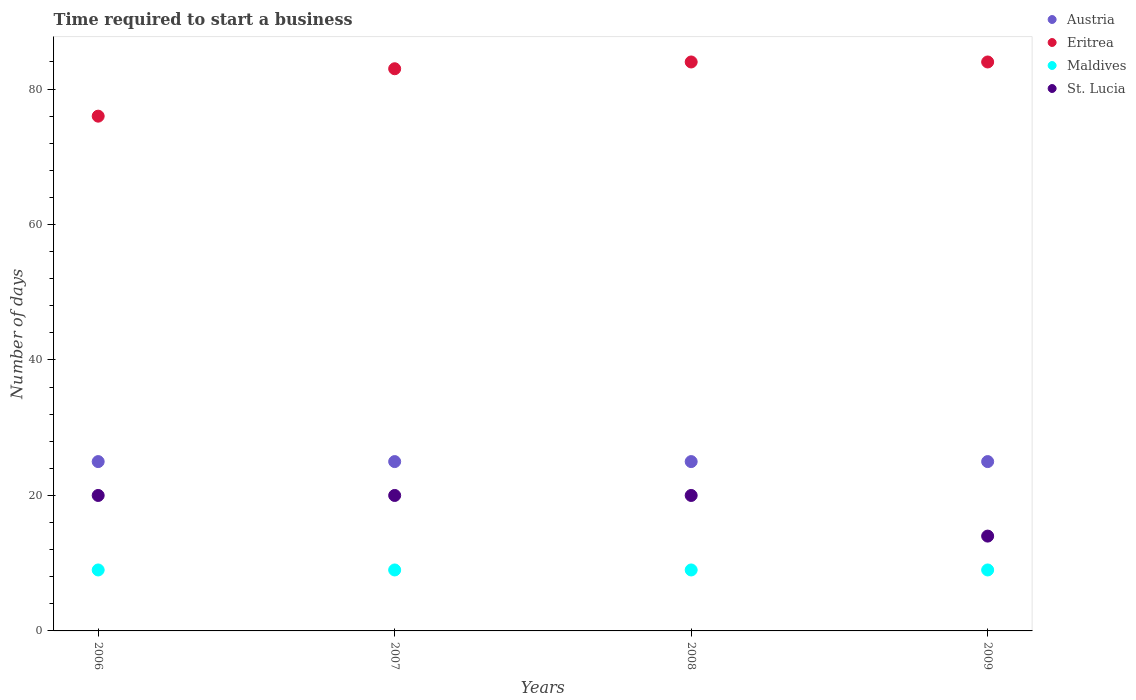How many different coloured dotlines are there?
Your answer should be very brief. 4. Is the number of dotlines equal to the number of legend labels?
Keep it short and to the point. Yes. What is the number of days required to start a business in Austria in 2006?
Your answer should be compact. 25. Across all years, what is the maximum number of days required to start a business in Maldives?
Your response must be concise. 9. Across all years, what is the minimum number of days required to start a business in Maldives?
Offer a very short reply. 9. In which year was the number of days required to start a business in St. Lucia maximum?
Provide a succinct answer. 2006. What is the total number of days required to start a business in Eritrea in the graph?
Your answer should be very brief. 327. What is the average number of days required to start a business in Maldives per year?
Offer a very short reply. 9. In how many years, is the number of days required to start a business in Eritrea greater than 80 days?
Ensure brevity in your answer.  3. What is the ratio of the number of days required to start a business in Maldives in 2008 to that in 2009?
Offer a terse response. 1. Is the number of days required to start a business in Austria in 2007 less than that in 2008?
Make the answer very short. No. Is the difference between the number of days required to start a business in Eritrea in 2006 and 2008 greater than the difference between the number of days required to start a business in St. Lucia in 2006 and 2008?
Give a very brief answer. No. Is it the case that in every year, the sum of the number of days required to start a business in Maldives and number of days required to start a business in St. Lucia  is greater than the sum of number of days required to start a business in Austria and number of days required to start a business in Eritrea?
Keep it short and to the point. No. Is the number of days required to start a business in Eritrea strictly less than the number of days required to start a business in Austria over the years?
Keep it short and to the point. No. How many dotlines are there?
Offer a terse response. 4. How many years are there in the graph?
Keep it short and to the point. 4. What is the difference between two consecutive major ticks on the Y-axis?
Give a very brief answer. 20. Does the graph contain any zero values?
Your response must be concise. No. Does the graph contain grids?
Give a very brief answer. No. How many legend labels are there?
Offer a terse response. 4. How are the legend labels stacked?
Your answer should be very brief. Vertical. What is the title of the graph?
Offer a very short reply. Time required to start a business. Does "Vanuatu" appear as one of the legend labels in the graph?
Provide a short and direct response. No. What is the label or title of the Y-axis?
Offer a terse response. Number of days. What is the Number of days of St. Lucia in 2006?
Make the answer very short. 20. What is the Number of days in Maldives in 2007?
Ensure brevity in your answer.  9. What is the Number of days of St. Lucia in 2007?
Provide a short and direct response. 20. What is the Number of days of Austria in 2008?
Provide a short and direct response. 25. What is the Number of days in Eritrea in 2008?
Ensure brevity in your answer.  84. What is the Number of days of Austria in 2009?
Make the answer very short. 25. What is the Number of days of Eritrea in 2009?
Keep it short and to the point. 84. What is the Number of days of Maldives in 2009?
Your answer should be very brief. 9. What is the Number of days in St. Lucia in 2009?
Your answer should be compact. 14. Across all years, what is the maximum Number of days of Austria?
Ensure brevity in your answer.  25. Across all years, what is the maximum Number of days in Maldives?
Ensure brevity in your answer.  9. Across all years, what is the maximum Number of days of St. Lucia?
Ensure brevity in your answer.  20. Across all years, what is the minimum Number of days of Austria?
Offer a very short reply. 25. Across all years, what is the minimum Number of days in Eritrea?
Ensure brevity in your answer.  76. Across all years, what is the minimum Number of days of St. Lucia?
Provide a succinct answer. 14. What is the total Number of days in Austria in the graph?
Provide a short and direct response. 100. What is the total Number of days of Eritrea in the graph?
Provide a short and direct response. 327. What is the total Number of days in Maldives in the graph?
Offer a terse response. 36. What is the total Number of days of St. Lucia in the graph?
Offer a very short reply. 74. What is the difference between the Number of days of Austria in 2006 and that in 2007?
Offer a very short reply. 0. What is the difference between the Number of days in Maldives in 2006 and that in 2007?
Ensure brevity in your answer.  0. What is the difference between the Number of days in St. Lucia in 2006 and that in 2007?
Ensure brevity in your answer.  0. What is the difference between the Number of days of St. Lucia in 2006 and that in 2008?
Your response must be concise. 0. What is the difference between the Number of days in Eritrea in 2006 and that in 2009?
Offer a very short reply. -8. What is the difference between the Number of days in Maldives in 2006 and that in 2009?
Ensure brevity in your answer.  0. What is the difference between the Number of days in Eritrea in 2007 and that in 2008?
Provide a succinct answer. -1. What is the difference between the Number of days in Maldives in 2007 and that in 2009?
Your response must be concise. 0. What is the difference between the Number of days in Austria in 2008 and that in 2009?
Provide a succinct answer. 0. What is the difference between the Number of days of Eritrea in 2008 and that in 2009?
Your response must be concise. 0. What is the difference between the Number of days of Austria in 2006 and the Number of days of Eritrea in 2007?
Keep it short and to the point. -58. What is the difference between the Number of days in Austria in 2006 and the Number of days in St. Lucia in 2007?
Your answer should be compact. 5. What is the difference between the Number of days in Eritrea in 2006 and the Number of days in Maldives in 2007?
Provide a succinct answer. 67. What is the difference between the Number of days in Maldives in 2006 and the Number of days in St. Lucia in 2007?
Provide a succinct answer. -11. What is the difference between the Number of days of Austria in 2006 and the Number of days of Eritrea in 2008?
Ensure brevity in your answer.  -59. What is the difference between the Number of days of Austria in 2006 and the Number of days of Maldives in 2008?
Provide a succinct answer. 16. What is the difference between the Number of days of Eritrea in 2006 and the Number of days of Maldives in 2008?
Your response must be concise. 67. What is the difference between the Number of days in Austria in 2006 and the Number of days in Eritrea in 2009?
Give a very brief answer. -59. What is the difference between the Number of days in Austria in 2006 and the Number of days in Maldives in 2009?
Your answer should be compact. 16. What is the difference between the Number of days of Austria in 2006 and the Number of days of St. Lucia in 2009?
Ensure brevity in your answer.  11. What is the difference between the Number of days in Austria in 2007 and the Number of days in Eritrea in 2008?
Your answer should be very brief. -59. What is the difference between the Number of days in Eritrea in 2007 and the Number of days in Maldives in 2008?
Ensure brevity in your answer.  74. What is the difference between the Number of days in Eritrea in 2007 and the Number of days in St. Lucia in 2008?
Offer a terse response. 63. What is the difference between the Number of days in Maldives in 2007 and the Number of days in St. Lucia in 2008?
Provide a succinct answer. -11. What is the difference between the Number of days of Austria in 2007 and the Number of days of Eritrea in 2009?
Provide a short and direct response. -59. What is the difference between the Number of days of Austria in 2007 and the Number of days of St. Lucia in 2009?
Offer a terse response. 11. What is the difference between the Number of days in Maldives in 2007 and the Number of days in St. Lucia in 2009?
Your answer should be very brief. -5. What is the difference between the Number of days in Austria in 2008 and the Number of days in Eritrea in 2009?
Your response must be concise. -59. What is the difference between the Number of days of Eritrea in 2008 and the Number of days of St. Lucia in 2009?
Offer a terse response. 70. What is the average Number of days in Eritrea per year?
Your answer should be compact. 81.75. What is the average Number of days in Maldives per year?
Make the answer very short. 9. What is the average Number of days of St. Lucia per year?
Ensure brevity in your answer.  18.5. In the year 2006, what is the difference between the Number of days in Austria and Number of days in Eritrea?
Offer a terse response. -51. In the year 2006, what is the difference between the Number of days in Eritrea and Number of days in Maldives?
Your response must be concise. 67. In the year 2007, what is the difference between the Number of days in Austria and Number of days in Eritrea?
Offer a terse response. -58. In the year 2007, what is the difference between the Number of days in Eritrea and Number of days in Maldives?
Offer a very short reply. 74. In the year 2007, what is the difference between the Number of days in Eritrea and Number of days in St. Lucia?
Offer a terse response. 63. In the year 2008, what is the difference between the Number of days in Austria and Number of days in Eritrea?
Your answer should be compact. -59. In the year 2008, what is the difference between the Number of days in Austria and Number of days in St. Lucia?
Your answer should be compact. 5. In the year 2008, what is the difference between the Number of days in Eritrea and Number of days in Maldives?
Your answer should be compact. 75. In the year 2009, what is the difference between the Number of days in Austria and Number of days in Eritrea?
Make the answer very short. -59. In the year 2009, what is the difference between the Number of days of Austria and Number of days of Maldives?
Offer a terse response. 16. In the year 2009, what is the difference between the Number of days of Austria and Number of days of St. Lucia?
Your response must be concise. 11. In the year 2009, what is the difference between the Number of days of Eritrea and Number of days of Maldives?
Your answer should be very brief. 75. In the year 2009, what is the difference between the Number of days in Eritrea and Number of days in St. Lucia?
Make the answer very short. 70. What is the ratio of the Number of days of Austria in 2006 to that in 2007?
Offer a very short reply. 1. What is the ratio of the Number of days in Eritrea in 2006 to that in 2007?
Provide a short and direct response. 0.92. What is the ratio of the Number of days of St. Lucia in 2006 to that in 2007?
Offer a terse response. 1. What is the ratio of the Number of days in Eritrea in 2006 to that in 2008?
Ensure brevity in your answer.  0.9. What is the ratio of the Number of days of Maldives in 2006 to that in 2008?
Offer a very short reply. 1. What is the ratio of the Number of days in St. Lucia in 2006 to that in 2008?
Make the answer very short. 1. What is the ratio of the Number of days of Austria in 2006 to that in 2009?
Give a very brief answer. 1. What is the ratio of the Number of days in Eritrea in 2006 to that in 2009?
Give a very brief answer. 0.9. What is the ratio of the Number of days of Maldives in 2006 to that in 2009?
Ensure brevity in your answer.  1. What is the ratio of the Number of days in St. Lucia in 2006 to that in 2009?
Offer a very short reply. 1.43. What is the ratio of the Number of days of Eritrea in 2007 to that in 2008?
Your answer should be compact. 0.99. What is the ratio of the Number of days in St. Lucia in 2007 to that in 2008?
Ensure brevity in your answer.  1. What is the ratio of the Number of days in Eritrea in 2007 to that in 2009?
Your answer should be very brief. 0.99. What is the ratio of the Number of days of St. Lucia in 2007 to that in 2009?
Provide a short and direct response. 1.43. What is the ratio of the Number of days of Eritrea in 2008 to that in 2009?
Keep it short and to the point. 1. What is the ratio of the Number of days of St. Lucia in 2008 to that in 2009?
Offer a terse response. 1.43. What is the difference between the highest and the second highest Number of days in St. Lucia?
Keep it short and to the point. 0. 